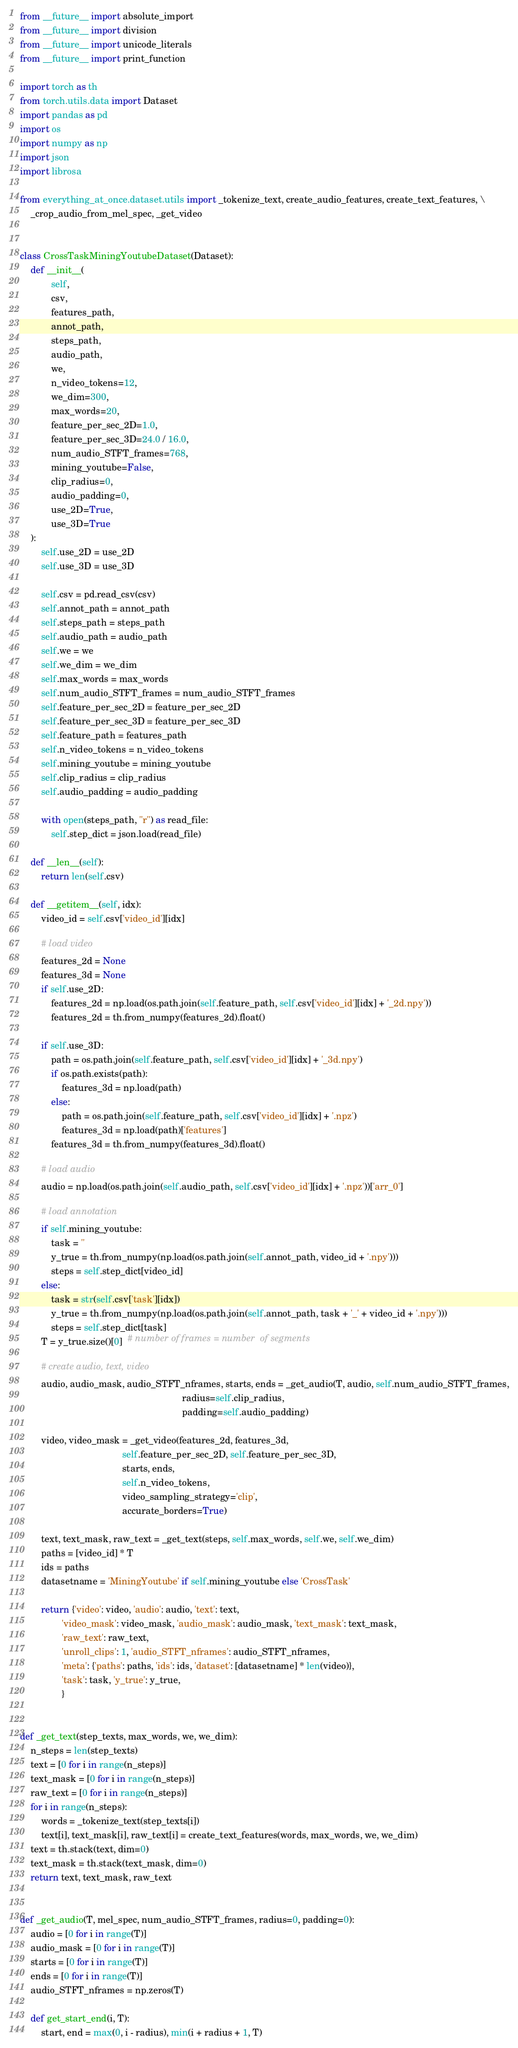<code> <loc_0><loc_0><loc_500><loc_500><_Python_>from __future__ import absolute_import
from __future__ import division
from __future__ import unicode_literals
from __future__ import print_function

import torch as th
from torch.utils.data import Dataset
import pandas as pd
import os
import numpy as np
import json
import librosa

from everything_at_once.dataset.utils import _tokenize_text, create_audio_features, create_text_features, \
    _crop_audio_from_mel_spec, _get_video


class CrossTaskMiningYoutubeDataset(Dataset):
    def __init__(
            self,
            csv,
            features_path,
            annot_path,
            steps_path,
            audio_path,
            we,
            n_video_tokens=12,
            we_dim=300,
            max_words=20,
            feature_per_sec_2D=1.0,
            feature_per_sec_3D=24.0 / 16.0,
            num_audio_STFT_frames=768,
            mining_youtube=False,
            clip_radius=0,
            audio_padding=0,
            use_2D=True,
            use_3D=True
    ):
        self.use_2D = use_2D
        self.use_3D = use_3D

        self.csv = pd.read_csv(csv)
        self.annot_path = annot_path
        self.steps_path = steps_path
        self.audio_path = audio_path
        self.we = we
        self.we_dim = we_dim
        self.max_words = max_words
        self.num_audio_STFT_frames = num_audio_STFT_frames
        self.feature_per_sec_2D = feature_per_sec_2D
        self.feature_per_sec_3D = feature_per_sec_3D
        self.feature_path = features_path
        self.n_video_tokens = n_video_tokens
        self.mining_youtube = mining_youtube
        self.clip_radius = clip_radius
        self.audio_padding = audio_padding

        with open(steps_path, "r") as read_file:
            self.step_dict = json.load(read_file)

    def __len__(self):
        return len(self.csv)

    def __getitem__(self, idx):
        video_id = self.csv['video_id'][idx]

        # load video
        features_2d = None
        features_3d = None
        if self.use_2D:
            features_2d = np.load(os.path.join(self.feature_path, self.csv['video_id'][idx] + '_2d.npy'))
            features_2d = th.from_numpy(features_2d).float()

        if self.use_3D:
            path = os.path.join(self.feature_path, self.csv['video_id'][idx] + '_3d.npy')
            if os.path.exists(path):
                features_3d = np.load(path)
            else:
                path = os.path.join(self.feature_path, self.csv['video_id'][idx] + '.npz')
                features_3d = np.load(path)['features']
            features_3d = th.from_numpy(features_3d).float()

        # load audio
        audio = np.load(os.path.join(self.audio_path, self.csv['video_id'][idx] + '.npz'))['arr_0']

        # load annotation
        if self.mining_youtube:
            task = ''
            y_true = th.from_numpy(np.load(os.path.join(self.annot_path, video_id + '.npy')))
            steps = self.step_dict[video_id]
        else:
            task = str(self.csv['task'][idx])
            y_true = th.from_numpy(np.load(os.path.join(self.annot_path, task + '_' + video_id + '.npy')))
            steps = self.step_dict[task]
        T = y_true.size()[0]  # number of frames = number  of segments

        # create audio, text, video
        audio, audio_mask, audio_STFT_nframes, starts, ends = _get_audio(T, audio, self.num_audio_STFT_frames,
                                                              radius=self.clip_radius,
                                                              padding=self.audio_padding)

        video, video_mask = _get_video(features_2d, features_3d,
                                       self.feature_per_sec_2D, self.feature_per_sec_3D,
                                       starts, ends,
                                       self.n_video_tokens,
                                       video_sampling_strategy='clip',
                                       accurate_borders=True)

        text, text_mask, raw_text = _get_text(steps, self.max_words, self.we, self.we_dim)
        paths = [video_id] * T
        ids = paths
        datasetname = 'MiningYoutube' if self.mining_youtube else 'CrossTask'

        return {'video': video, 'audio': audio, 'text': text,
                'video_mask': video_mask, 'audio_mask': audio_mask, 'text_mask': text_mask,
                'raw_text': raw_text,
                'unroll_clips': 1, 'audio_STFT_nframes': audio_STFT_nframes,
                'meta': {'paths': paths, 'ids': ids, 'dataset': [datasetname] * len(video)},
                'task': task, 'y_true': y_true,
                }


def _get_text(step_texts, max_words, we, we_dim):
    n_steps = len(step_texts)
    text = [0 for i in range(n_steps)]
    text_mask = [0 for i in range(n_steps)]
    raw_text = [0 for i in range(n_steps)]
    for i in range(n_steps):
        words = _tokenize_text(step_texts[i])
        text[i], text_mask[i], raw_text[i] = create_text_features(words, max_words, we, we_dim)
    text = th.stack(text, dim=0)
    text_mask = th.stack(text_mask, dim=0)
    return text, text_mask, raw_text


def _get_audio(T, mel_spec, num_audio_STFT_frames, radius=0, padding=0):
    audio = [0 for i in range(T)]
    audio_mask = [0 for i in range(T)]
    starts = [0 for i in range(T)]
    ends = [0 for i in range(T)]
    audio_STFT_nframes = np.zeros(T)

    def get_start_end(i, T):
        start, end = max(0, i - radius), min(i + radius + 1, T)</code> 